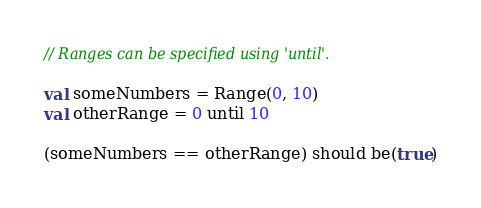Convert code to text. <code><loc_0><loc_0><loc_500><loc_500><_Scala_>// Ranges can be specified using 'until'.

val someNumbers = Range(0, 10)
val otherRange = 0 until 10

(someNumbers == otherRange) should be(true)</code> 